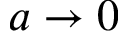<formula> <loc_0><loc_0><loc_500><loc_500>{ a \to 0 }</formula> 